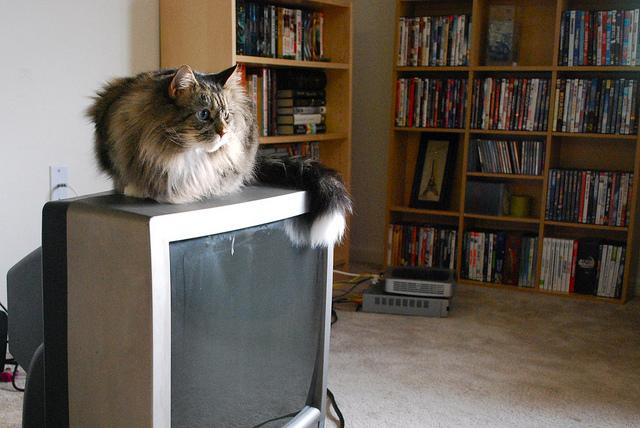Who is allowing the cat to lay on the computer?
Answer briefly. Owner. What is this cat doing?
Keep it brief. Sitting. Is this room carpeted?
Answer briefly. Yes. Is this a flat screen TV?
Quick response, please. No. 